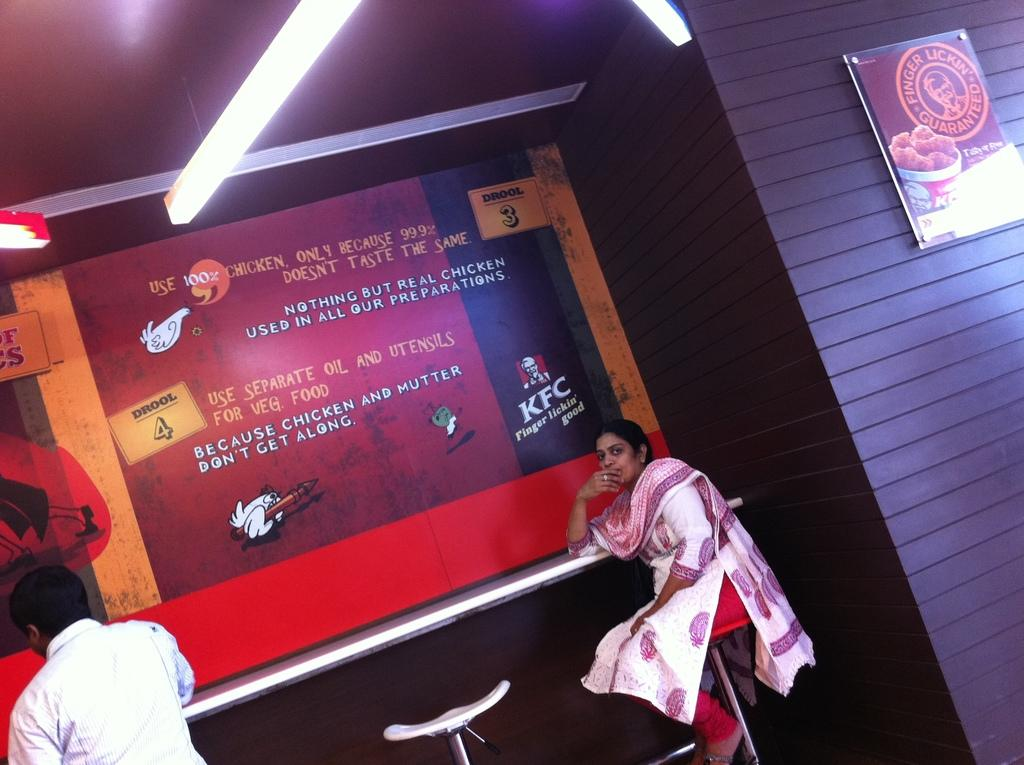<image>
Offer a succinct explanation of the picture presented. A woman sits at a counter beneath a large Kentucky Fried Chicken display. 